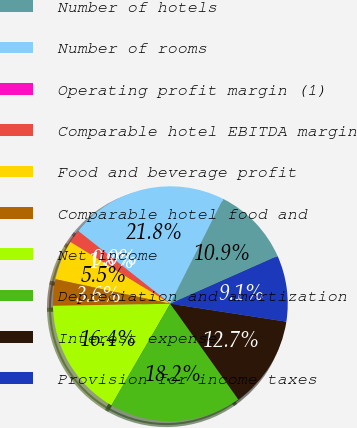Convert chart. <chart><loc_0><loc_0><loc_500><loc_500><pie_chart><fcel>Number of hotels<fcel>Number of rooms<fcel>Operating profit margin (1)<fcel>Comparable hotel EBITDA margin<fcel>Food and beverage profit<fcel>Comparable hotel food and<fcel>Net income<fcel>Depreciation and amortization<fcel>Interest expense<fcel>Provision for income taxes<nl><fcel>10.91%<fcel>21.81%<fcel>0.0%<fcel>1.82%<fcel>5.46%<fcel>3.64%<fcel>16.36%<fcel>18.18%<fcel>12.73%<fcel>9.09%<nl></chart> 